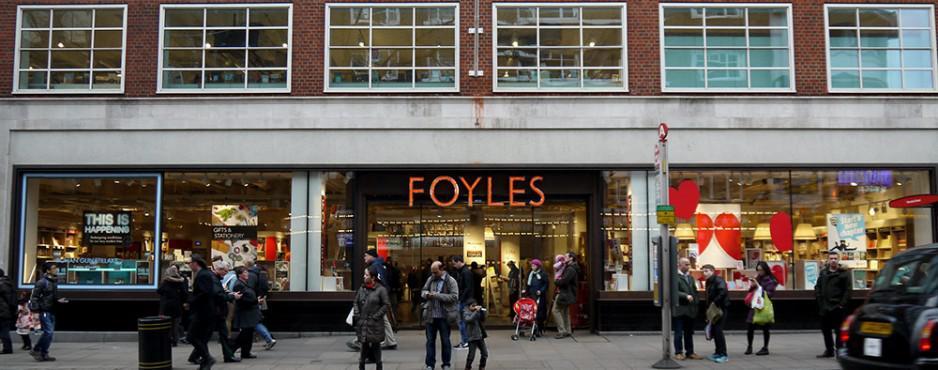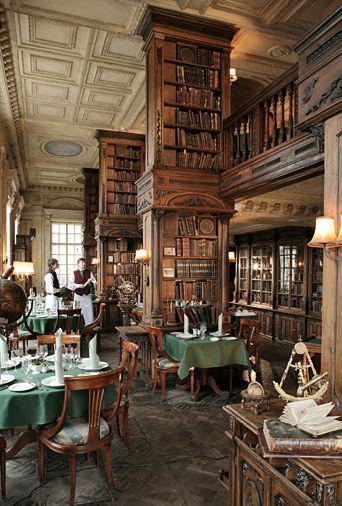The first image is the image on the left, the second image is the image on the right. Analyze the images presented: Is the assertion "At least one person is walking outside of one of the stores." valid? Answer yes or no. Yes. The first image is the image on the left, the second image is the image on the right. For the images displayed, is the sentence "There is a storefront in each image." factually correct? Answer yes or no. No. 